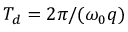Convert formula to latex. <formula><loc_0><loc_0><loc_500><loc_500>T _ { d } = 2 \pi / ( \omega _ { 0 } q )</formula> 